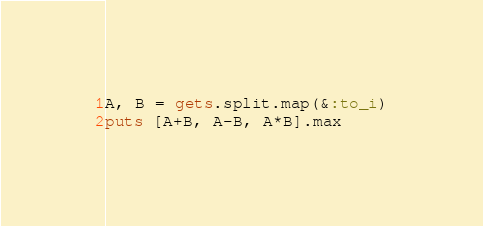Convert code to text. <code><loc_0><loc_0><loc_500><loc_500><_Ruby_>A, B = gets.split.map(&:to_i)
puts [A+B, A-B, A*B].max
</code> 